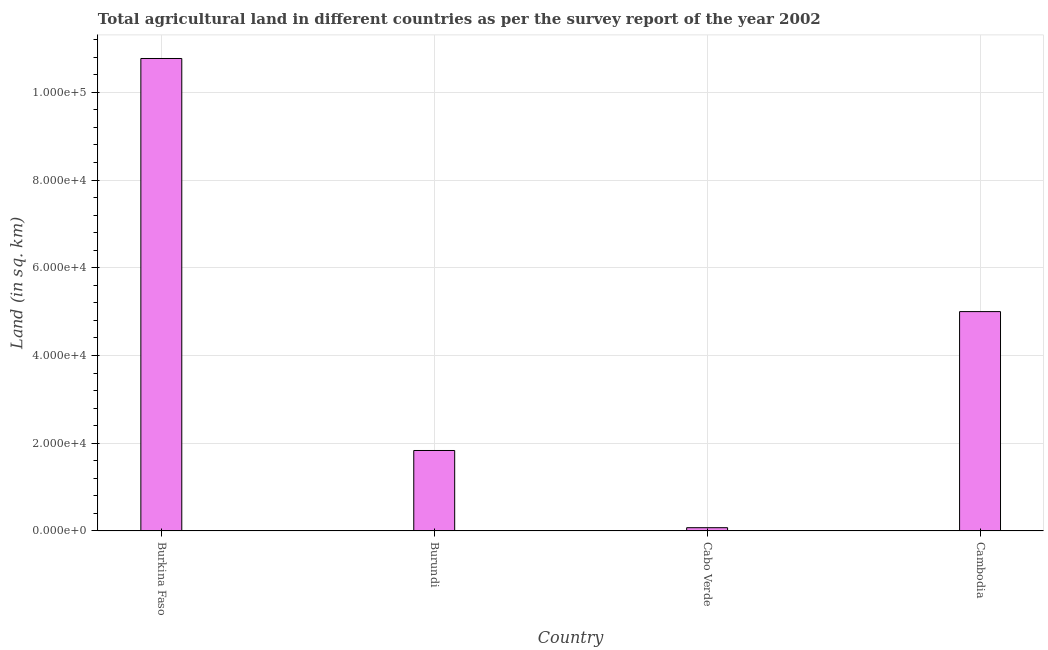Does the graph contain any zero values?
Ensure brevity in your answer.  No. What is the title of the graph?
Offer a terse response. Total agricultural land in different countries as per the survey report of the year 2002. What is the label or title of the X-axis?
Offer a very short reply. Country. What is the label or title of the Y-axis?
Offer a very short reply. Land (in sq. km). What is the agricultural land in Cabo Verde?
Keep it short and to the point. 740. Across all countries, what is the maximum agricultural land?
Your response must be concise. 1.08e+05. Across all countries, what is the minimum agricultural land?
Offer a terse response. 740. In which country was the agricultural land maximum?
Ensure brevity in your answer.  Burkina Faso. In which country was the agricultural land minimum?
Your answer should be very brief. Cabo Verde. What is the sum of the agricultural land?
Keep it short and to the point. 1.77e+05. What is the difference between the agricultural land in Cabo Verde and Cambodia?
Keep it short and to the point. -4.93e+04. What is the average agricultural land per country?
Your answer should be very brief. 4.42e+04. What is the median agricultural land?
Ensure brevity in your answer.  3.42e+04. In how many countries, is the agricultural land greater than 52000 sq. km?
Make the answer very short. 1. What is the ratio of the agricultural land in Burkina Faso to that in Cambodia?
Give a very brief answer. 2.15. What is the difference between the highest and the second highest agricultural land?
Your answer should be compact. 5.77e+04. What is the difference between the highest and the lowest agricultural land?
Offer a terse response. 1.07e+05. In how many countries, is the agricultural land greater than the average agricultural land taken over all countries?
Offer a terse response. 2. How many countries are there in the graph?
Your answer should be very brief. 4. Are the values on the major ticks of Y-axis written in scientific E-notation?
Ensure brevity in your answer.  Yes. What is the Land (in sq. km) of Burkina Faso?
Offer a very short reply. 1.08e+05. What is the Land (in sq. km) in Burundi?
Provide a short and direct response. 1.83e+04. What is the Land (in sq. km) of Cabo Verde?
Provide a short and direct response. 740. What is the difference between the Land (in sq. km) in Burkina Faso and Burundi?
Your answer should be very brief. 8.94e+04. What is the difference between the Land (in sq. km) in Burkina Faso and Cabo Verde?
Provide a succinct answer. 1.07e+05. What is the difference between the Land (in sq. km) in Burkina Faso and Cambodia?
Provide a short and direct response. 5.77e+04. What is the difference between the Land (in sq. km) in Burundi and Cabo Verde?
Give a very brief answer. 1.76e+04. What is the difference between the Land (in sq. km) in Burundi and Cambodia?
Provide a succinct answer. -3.17e+04. What is the difference between the Land (in sq. km) in Cabo Verde and Cambodia?
Keep it short and to the point. -4.93e+04. What is the ratio of the Land (in sq. km) in Burkina Faso to that in Burundi?
Offer a terse response. 5.87. What is the ratio of the Land (in sq. km) in Burkina Faso to that in Cabo Verde?
Your response must be concise. 145.54. What is the ratio of the Land (in sq. km) in Burkina Faso to that in Cambodia?
Provide a succinct answer. 2.15. What is the ratio of the Land (in sq. km) in Burundi to that in Cabo Verde?
Keep it short and to the point. 24.78. What is the ratio of the Land (in sq. km) in Burundi to that in Cambodia?
Offer a terse response. 0.37. What is the ratio of the Land (in sq. km) in Cabo Verde to that in Cambodia?
Keep it short and to the point. 0.01. 